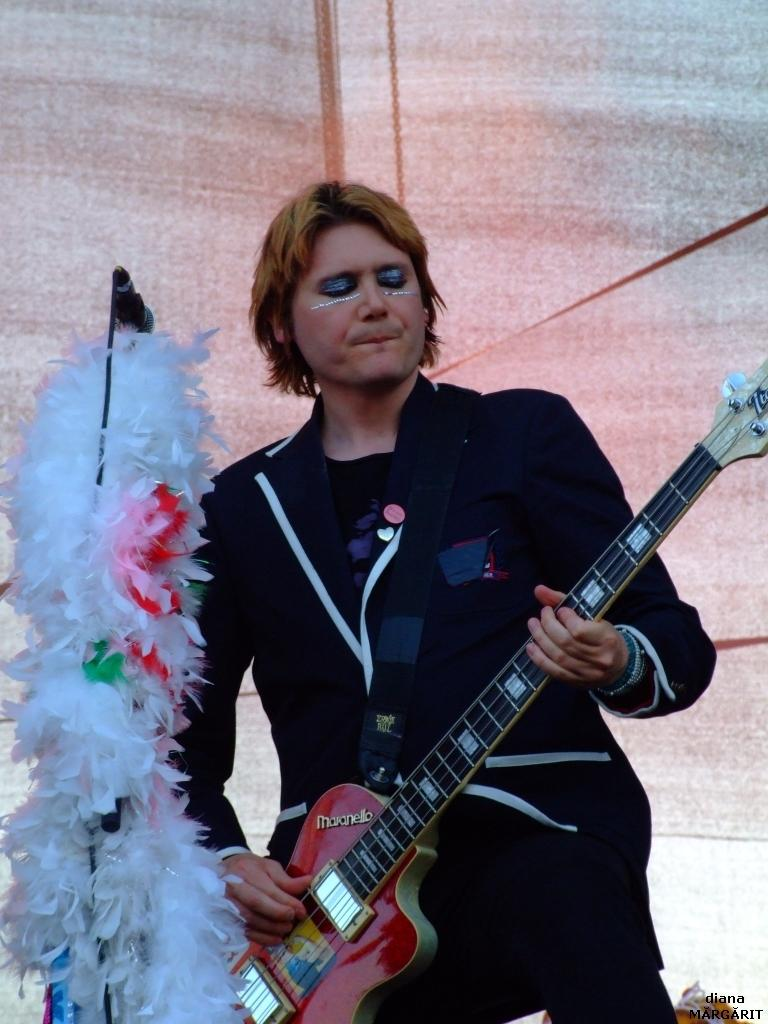What is the person in the image doing? The person is standing in the image and holding a guitar. What object is present in the image that is typically used for amplifying sound? There is a microphone in the image. What is the person likely to use to support the guitar while playing? There is a stand in the image that can be used to support the guitar. What type of grass can be seen growing in the middle of the image? There is no grass present in the image; it features a person holding a guitar, a microphone, and a stand. What tool is the person using to cut the strings of the guitar in the image? There is no tool or action of cutting guitar strings in the image. 